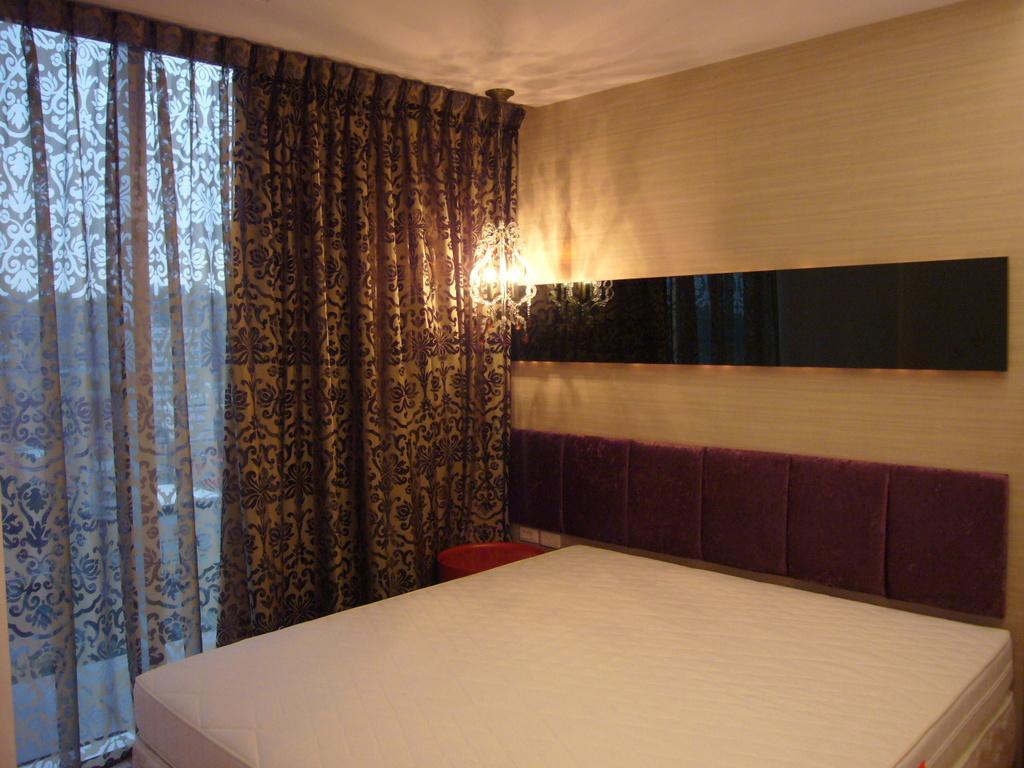Describe this image in one or two sentences. In this picture there is a white bed. Behind a Brown cushion and wooden panel wall. On the left side there is a brown curtain with table light. 